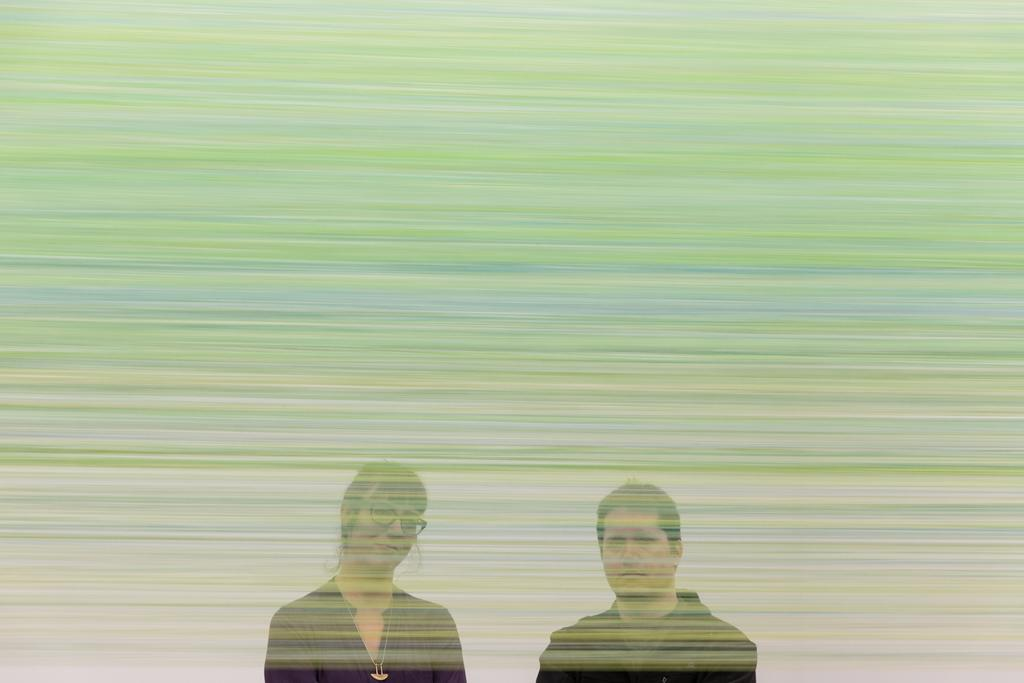How many people are in the image wearing black color dress? There are two people wearing black color dress in the image. Can you describe the appearance of one of the people in the image? One person in the image is wearing specs. What colors can be seen in the background of the image? The background of the image has green and blue color shades. What type of mint is being used as a decoration in the image? There is no mint present in the image; it features two people wearing black color dress and a background with green and blue color shades. 